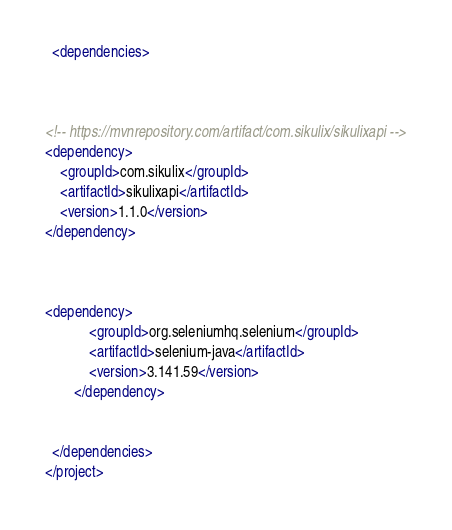Convert code to text. <code><loc_0><loc_0><loc_500><loc_500><_XML_>  <dependencies>
    
    
	
<!-- https://mvnrepository.com/artifact/com.sikulix/sikulixapi -->
<dependency>
    <groupId>com.sikulix</groupId>
    <artifactId>sikulixapi</artifactId>
    <version>1.1.0</version>
</dependency>



<dependency>
			<groupId>org.seleniumhq.selenium</groupId>
			<artifactId>selenium-java</artifactId>
			<version>3.141.59</version>
		</dependency>

    
  </dependencies>
</project>
</code> 